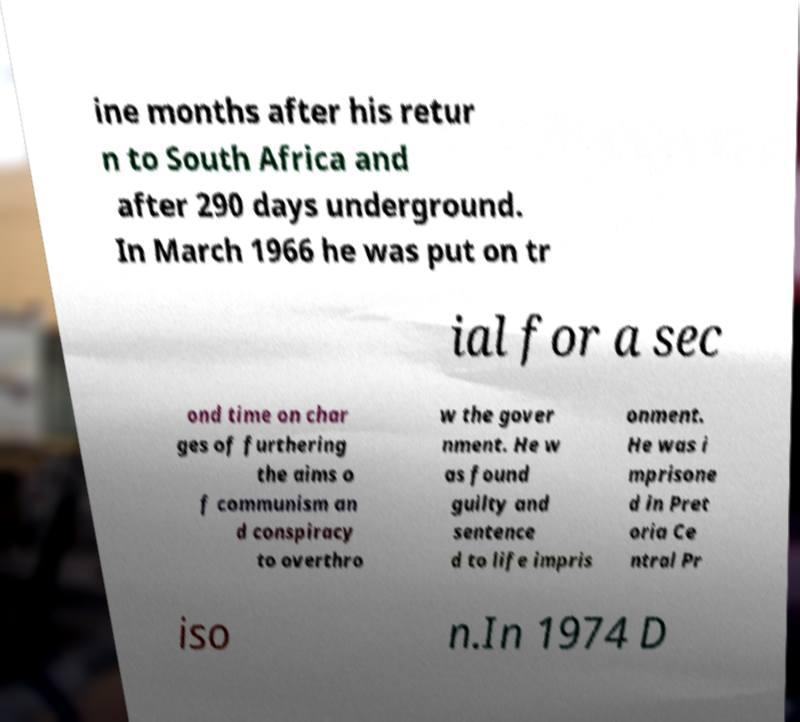There's text embedded in this image that I need extracted. Can you transcribe it verbatim? ine months after his retur n to South Africa and after 290 days underground. In March 1966 he was put on tr ial for a sec ond time on char ges of furthering the aims o f communism an d conspiracy to overthro w the gover nment. He w as found guilty and sentence d to life impris onment. He was i mprisone d in Pret oria Ce ntral Pr iso n.In 1974 D 